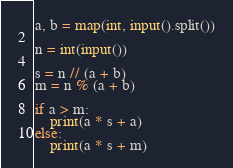<code> <loc_0><loc_0><loc_500><loc_500><_Python_>a, b = map(int, input().split())

n = int(input())

s = n // (a + b)
m = n % (a + b)

if a > m:
    print(a * s + a)
else:
    print(a * s + m)</code> 